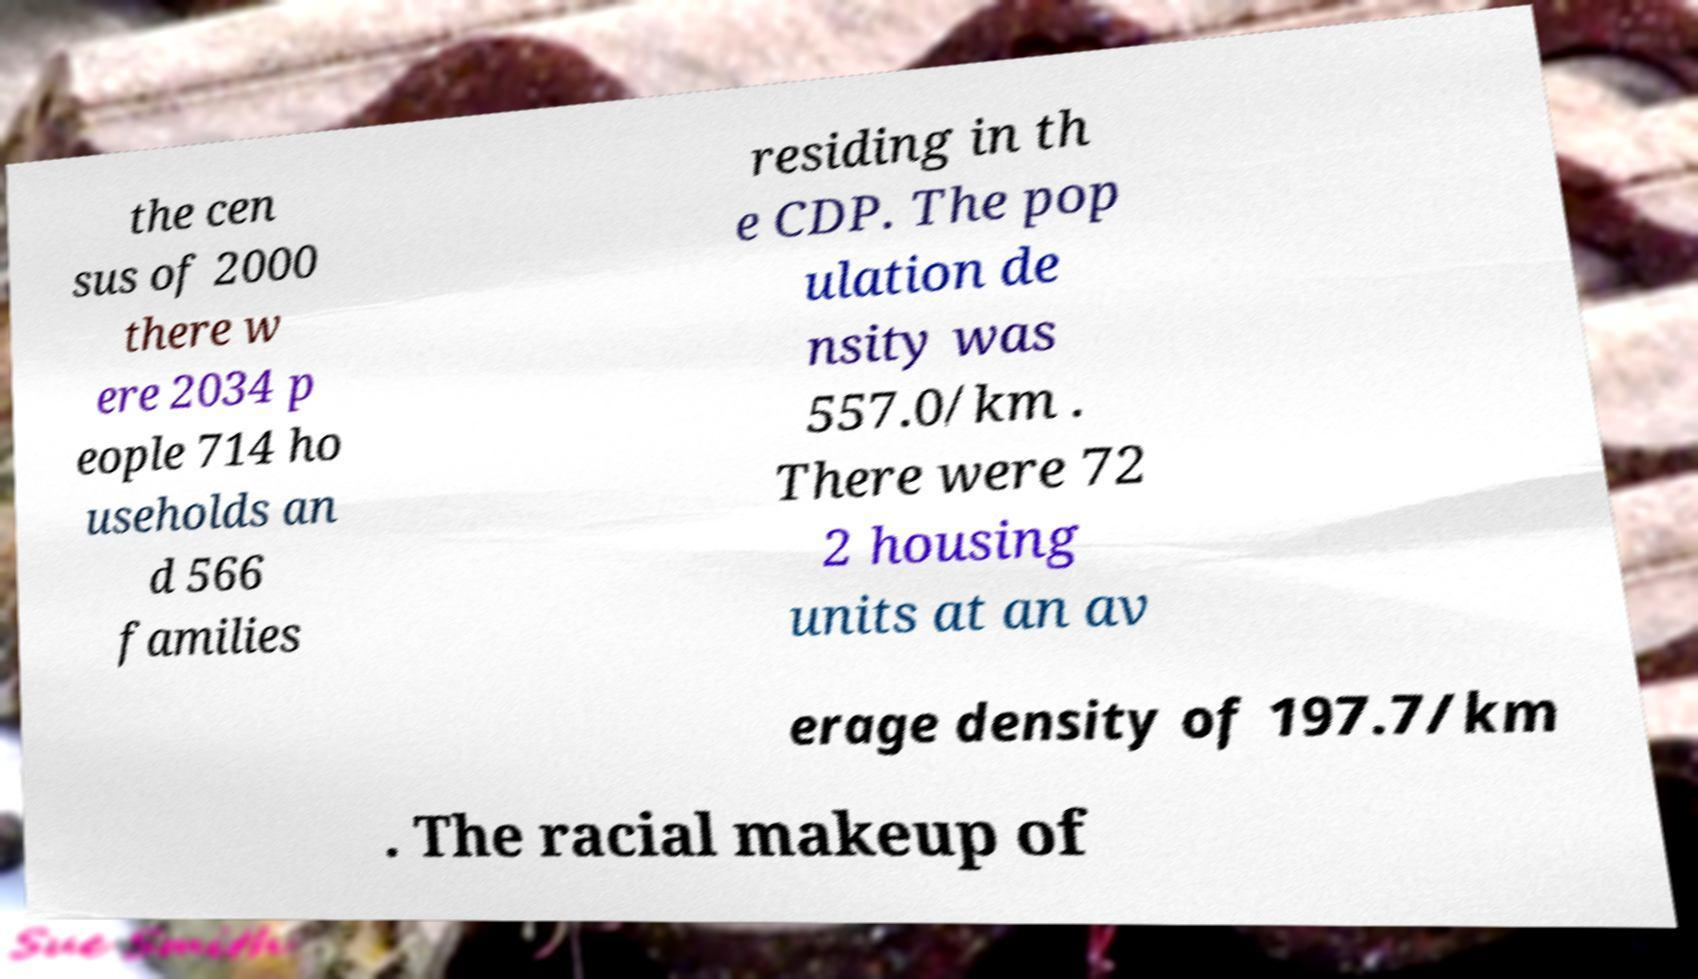Please read and relay the text visible in this image. What does it say? the cen sus of 2000 there w ere 2034 p eople 714 ho useholds an d 566 families residing in th e CDP. The pop ulation de nsity was 557.0/km . There were 72 2 housing units at an av erage density of 197.7/km . The racial makeup of 